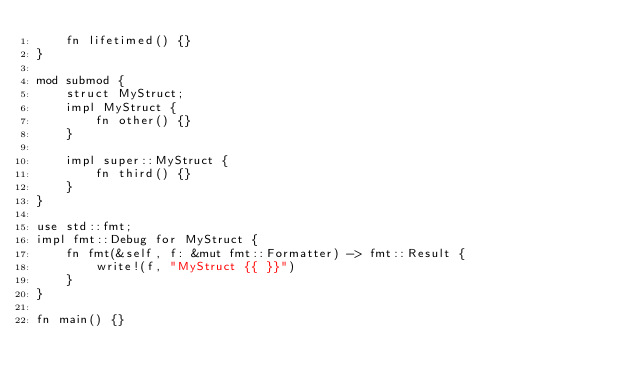<code> <loc_0><loc_0><loc_500><loc_500><_Rust_>    fn lifetimed() {}
}

mod submod {
    struct MyStruct;
    impl MyStruct {
        fn other() {}
    }

    impl super::MyStruct {
        fn third() {}
    }
}

use std::fmt;
impl fmt::Debug for MyStruct {
    fn fmt(&self, f: &mut fmt::Formatter) -> fmt::Result {
        write!(f, "MyStruct {{ }}")
    }
}

fn main() {}
</code> 